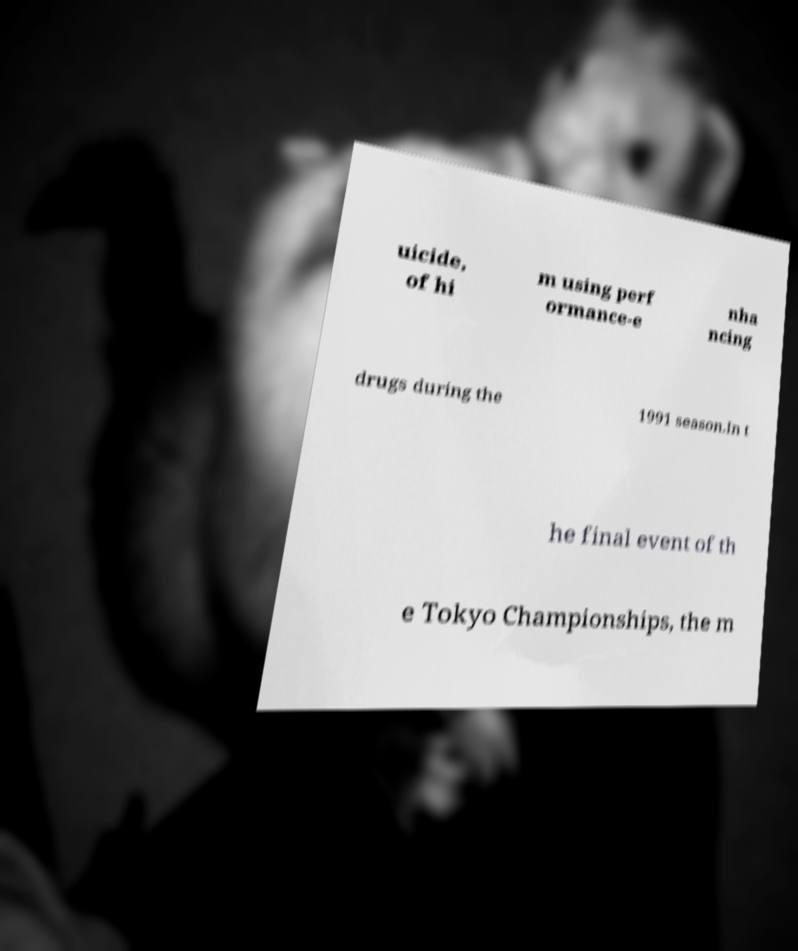Could you extract and type out the text from this image? uicide, of hi m using perf ormance-e nha ncing drugs during the 1991 season.In t he final event of th e Tokyo Championships, the m 